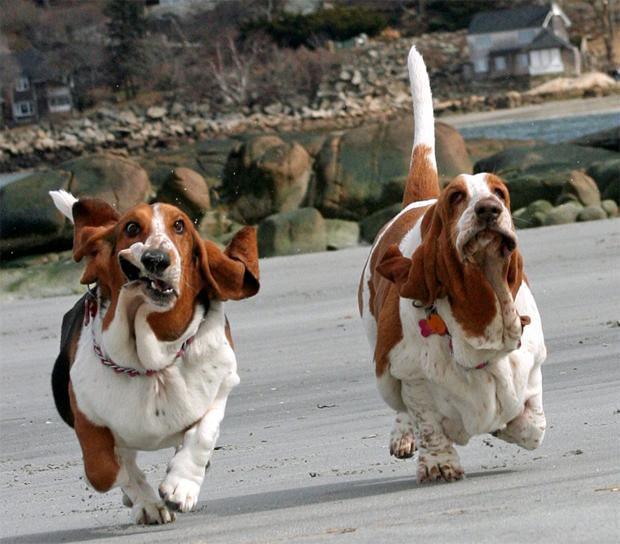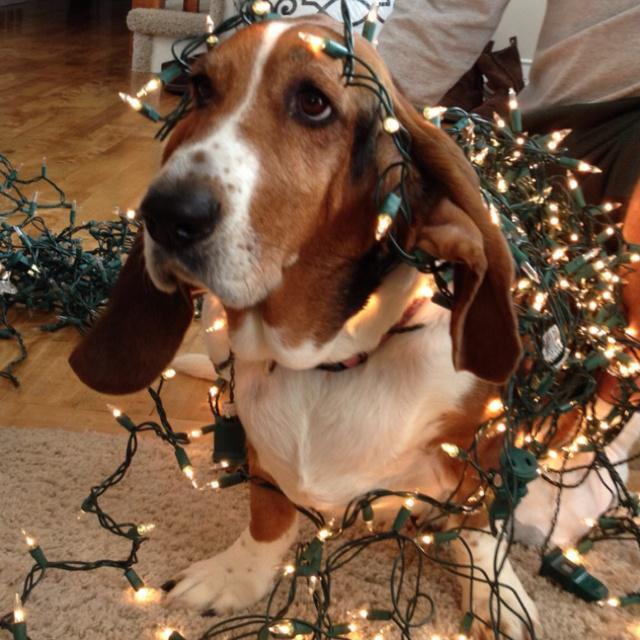The first image is the image on the left, the second image is the image on the right. For the images shown, is this caption "There are at least two dogs walking in the same direction." true? Answer yes or no. Yes. The first image is the image on the left, the second image is the image on the right. Considering the images on both sides, is "There are three dogs." valid? Answer yes or no. Yes. 